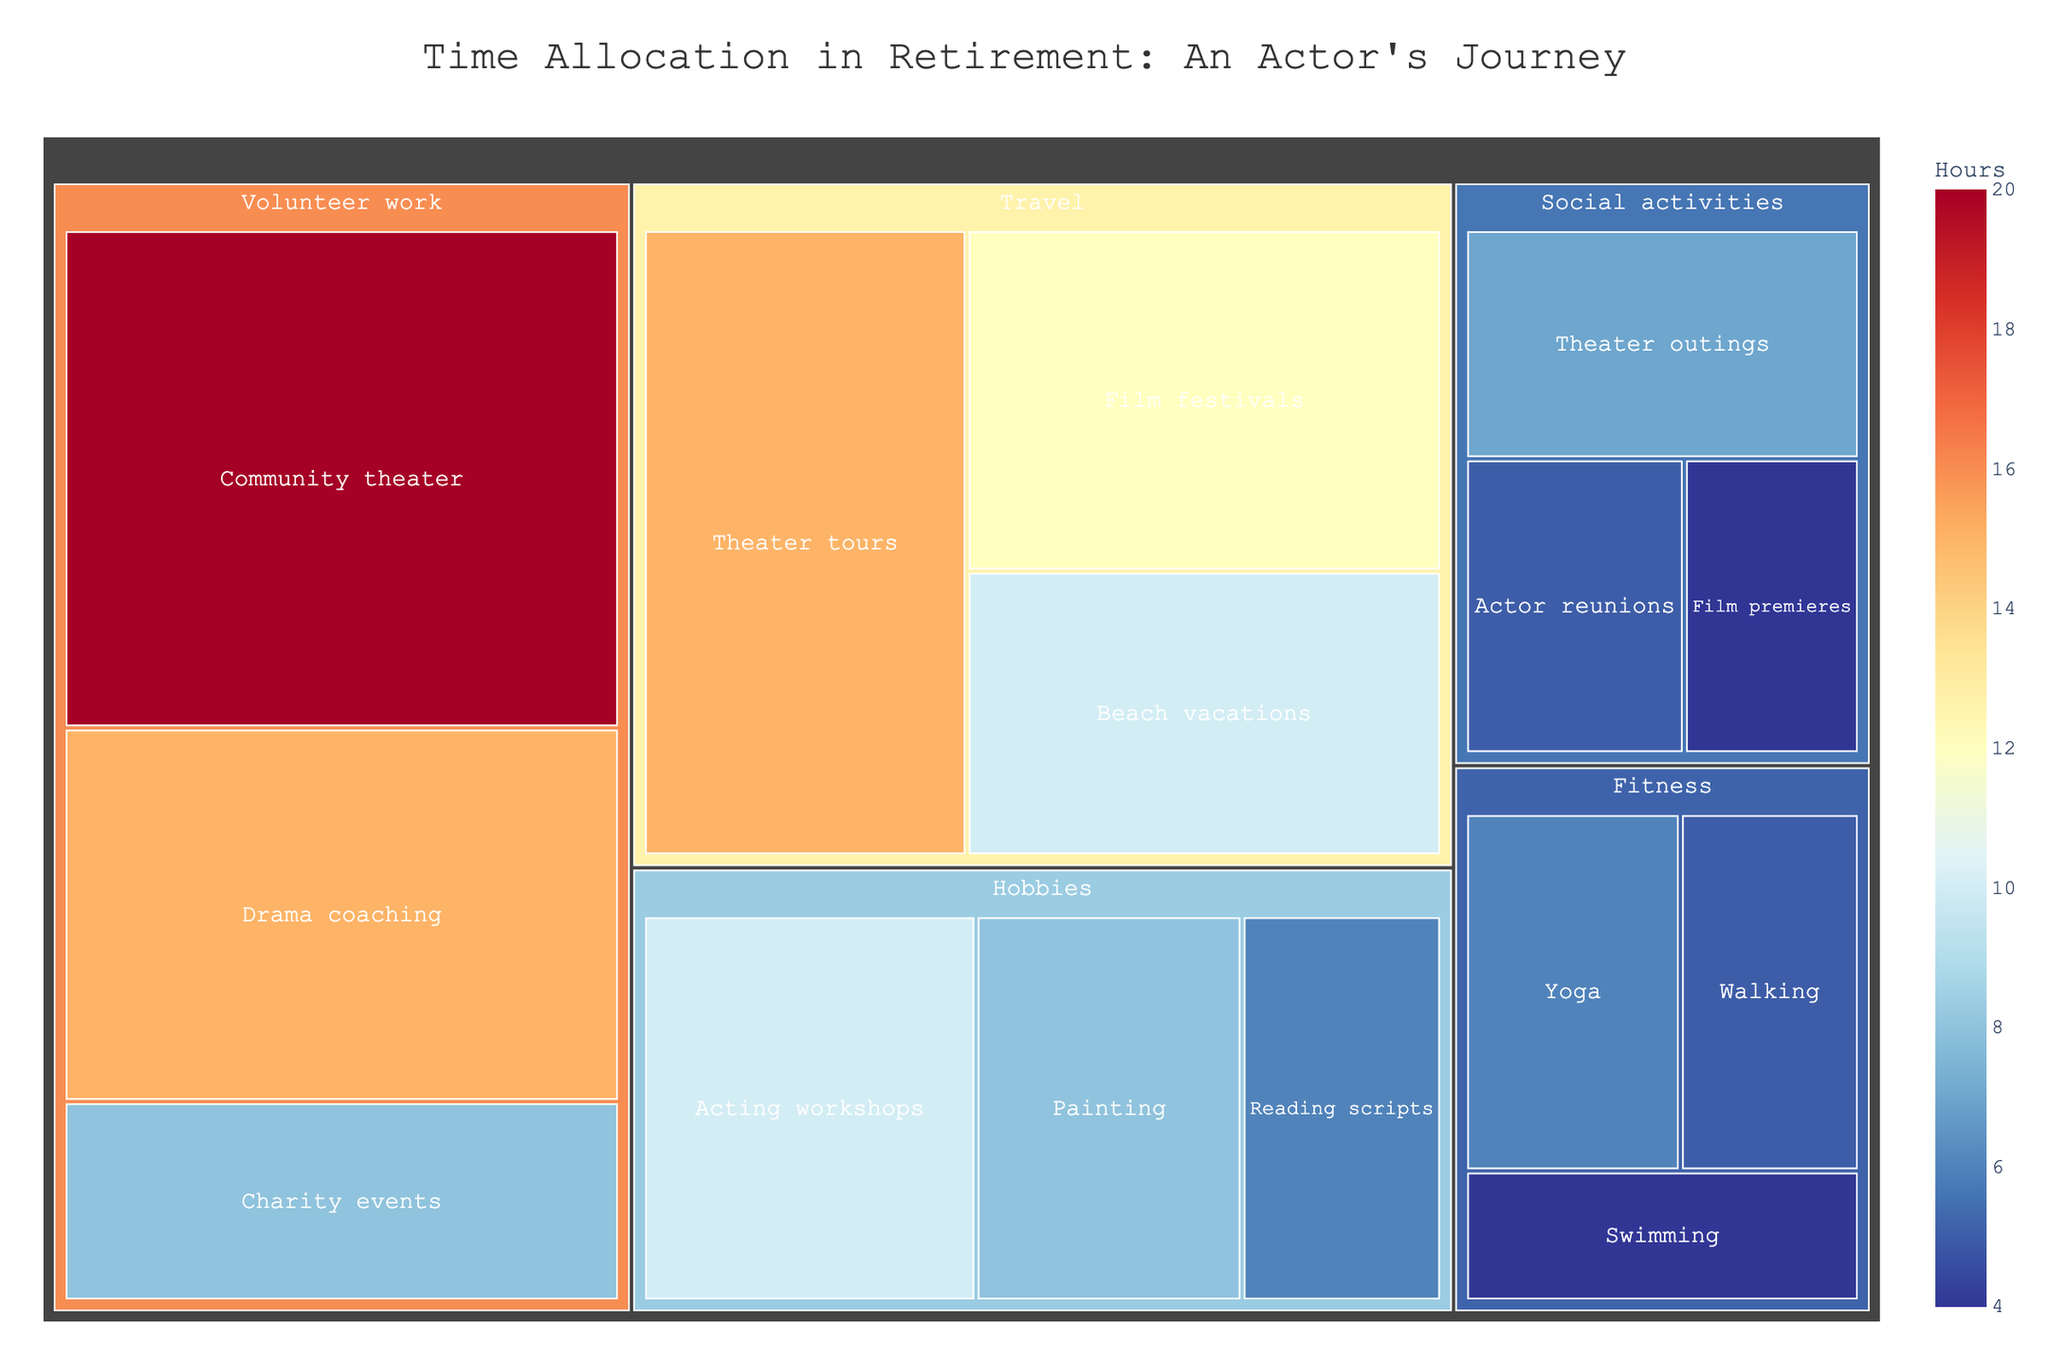What is the title of the treemap? The title is displayed at the top of the treemap, right above the visualization.
Answer: Time Allocation in Retirement: An Actor's Journey Which category has the highest total hours? By examining the color intensity and size of the blocks, the category with the darkest and largest block represents the highest total hours.
Answer: Volunteer work How many more hours are spent on acting workshops compared to film premieres? Locate the hours for acting workshops and film premieres. Acting workshops are 10 hours, and film premieres are 4 hours. Subtract the smaller value from the larger one.
Answer: 6 hours What subcategory within Volunteer work has the most hours? Within the Volunteer work category, the subcategory with the largest block represents the most hours.
Answer: Community theater Which activity in the Social activities category takes up the least amount of time? Examine the blocks under Social activities and pick the one with the smallest area.
Answer: Film premieres How many total hours are spent on fitness activities? Sum the hours for all subcategories under Fitness: Yoga (6), Swimming (4), and Walking (5). Total is 6 + 4 + 5 = 15.
Answer: 15 hours Does Painting or Reading scripts take up more time? Compare the hours listed for Painting and Reading scripts by looking at their respective blocks.
Answer: Painting By how many hours do community theater activities exceed swimming activities? Find the hours for community theater and swimming. Community theater is 20 hours, and swimming is 4 hours. Subtract the smaller value from the larger one.
Answer: 16 hours Which subcategory in Travel has the second highest time allocation? Look at the blocks under Travel and identify the one with the second largest area.
Answer: Film festivals What's the combined time spent on travel-related theater tours and hobbies-related painting? Add the hours from theater tours (15) and painting (8). The combined total is 15 + 8 = 23 hours.
Answer: 23 hours 